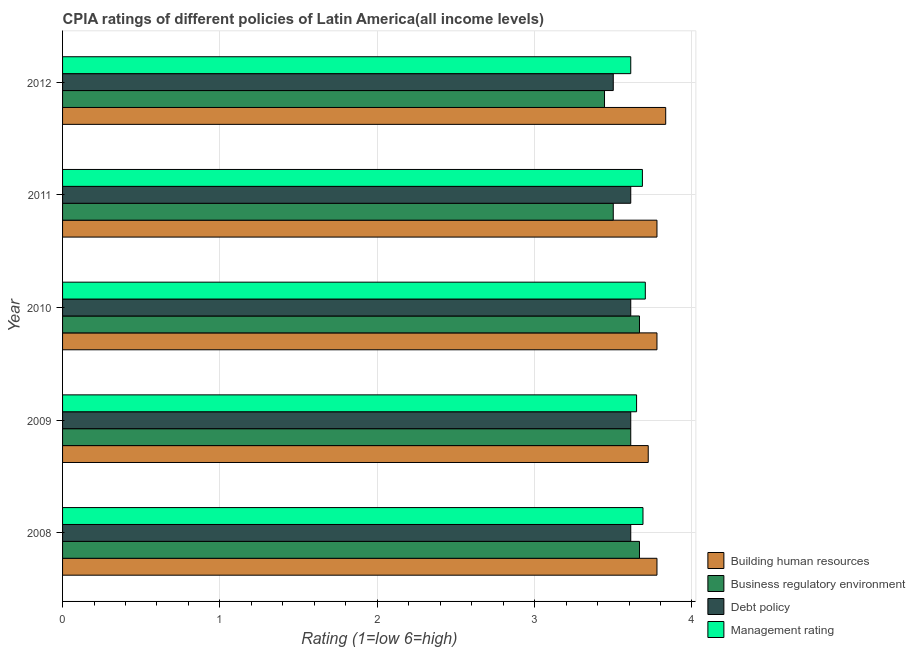Are the number of bars per tick equal to the number of legend labels?
Provide a short and direct response. Yes. What is the label of the 1st group of bars from the top?
Provide a short and direct response. 2012. In how many cases, is the number of bars for a given year not equal to the number of legend labels?
Your answer should be very brief. 0. What is the cpia rating of management in 2012?
Provide a succinct answer. 3.61. Across all years, what is the maximum cpia rating of business regulatory environment?
Keep it short and to the point. 3.67. Across all years, what is the minimum cpia rating of management?
Keep it short and to the point. 3.61. In which year was the cpia rating of debt policy maximum?
Your answer should be very brief. 2008. What is the total cpia rating of business regulatory environment in the graph?
Ensure brevity in your answer.  17.89. What is the difference between the cpia rating of business regulatory environment in 2009 and the cpia rating of building human resources in 2010?
Make the answer very short. -0.17. What is the average cpia rating of debt policy per year?
Make the answer very short. 3.59. In the year 2012, what is the difference between the cpia rating of management and cpia rating of business regulatory environment?
Your answer should be very brief. 0.17. In how many years, is the cpia rating of management greater than 2.6 ?
Keep it short and to the point. 5. What is the ratio of the cpia rating of debt policy in 2009 to that in 2011?
Give a very brief answer. 1. Is the difference between the cpia rating of business regulatory environment in 2011 and 2012 greater than the difference between the cpia rating of debt policy in 2011 and 2012?
Provide a succinct answer. No. What is the difference between the highest and the second highest cpia rating of building human resources?
Provide a succinct answer. 0.06. What is the difference between the highest and the lowest cpia rating of debt policy?
Ensure brevity in your answer.  0.11. Is it the case that in every year, the sum of the cpia rating of business regulatory environment and cpia rating of management is greater than the sum of cpia rating of building human resources and cpia rating of debt policy?
Give a very brief answer. No. What does the 3rd bar from the top in 2009 represents?
Offer a very short reply. Business regulatory environment. What does the 3rd bar from the bottom in 2008 represents?
Provide a short and direct response. Debt policy. Are all the bars in the graph horizontal?
Ensure brevity in your answer.  Yes. How many years are there in the graph?
Keep it short and to the point. 5. Are the values on the major ticks of X-axis written in scientific E-notation?
Provide a succinct answer. No. Does the graph contain any zero values?
Your answer should be compact. No. How are the legend labels stacked?
Offer a terse response. Vertical. What is the title of the graph?
Your answer should be compact. CPIA ratings of different policies of Latin America(all income levels). Does "Luxembourg" appear as one of the legend labels in the graph?
Provide a short and direct response. No. What is the label or title of the Y-axis?
Ensure brevity in your answer.  Year. What is the Rating (1=low 6=high) in Building human resources in 2008?
Make the answer very short. 3.78. What is the Rating (1=low 6=high) in Business regulatory environment in 2008?
Make the answer very short. 3.67. What is the Rating (1=low 6=high) of Debt policy in 2008?
Your answer should be very brief. 3.61. What is the Rating (1=low 6=high) in Management rating in 2008?
Keep it short and to the point. 3.69. What is the Rating (1=low 6=high) of Building human resources in 2009?
Offer a very short reply. 3.72. What is the Rating (1=low 6=high) in Business regulatory environment in 2009?
Your response must be concise. 3.61. What is the Rating (1=low 6=high) of Debt policy in 2009?
Your answer should be compact. 3.61. What is the Rating (1=low 6=high) in Management rating in 2009?
Offer a terse response. 3.65. What is the Rating (1=low 6=high) of Building human resources in 2010?
Your answer should be very brief. 3.78. What is the Rating (1=low 6=high) in Business regulatory environment in 2010?
Make the answer very short. 3.67. What is the Rating (1=low 6=high) of Debt policy in 2010?
Provide a succinct answer. 3.61. What is the Rating (1=low 6=high) in Management rating in 2010?
Ensure brevity in your answer.  3.7. What is the Rating (1=low 6=high) in Building human resources in 2011?
Provide a succinct answer. 3.78. What is the Rating (1=low 6=high) of Debt policy in 2011?
Make the answer very short. 3.61. What is the Rating (1=low 6=high) in Management rating in 2011?
Your response must be concise. 3.69. What is the Rating (1=low 6=high) of Building human resources in 2012?
Provide a succinct answer. 3.83. What is the Rating (1=low 6=high) in Business regulatory environment in 2012?
Make the answer very short. 3.44. What is the Rating (1=low 6=high) of Management rating in 2012?
Provide a succinct answer. 3.61. Across all years, what is the maximum Rating (1=low 6=high) in Building human resources?
Your answer should be very brief. 3.83. Across all years, what is the maximum Rating (1=low 6=high) of Business regulatory environment?
Make the answer very short. 3.67. Across all years, what is the maximum Rating (1=low 6=high) of Debt policy?
Offer a very short reply. 3.61. Across all years, what is the maximum Rating (1=low 6=high) in Management rating?
Offer a very short reply. 3.7. Across all years, what is the minimum Rating (1=low 6=high) of Building human resources?
Keep it short and to the point. 3.72. Across all years, what is the minimum Rating (1=low 6=high) in Business regulatory environment?
Give a very brief answer. 3.44. Across all years, what is the minimum Rating (1=low 6=high) of Debt policy?
Provide a short and direct response. 3.5. Across all years, what is the minimum Rating (1=low 6=high) in Management rating?
Your answer should be very brief. 3.61. What is the total Rating (1=low 6=high) of Building human resources in the graph?
Ensure brevity in your answer.  18.89. What is the total Rating (1=low 6=high) in Business regulatory environment in the graph?
Offer a terse response. 17.89. What is the total Rating (1=low 6=high) of Debt policy in the graph?
Your answer should be compact. 17.94. What is the total Rating (1=low 6=high) in Management rating in the graph?
Keep it short and to the point. 18.34. What is the difference between the Rating (1=low 6=high) of Building human resources in 2008 and that in 2009?
Your answer should be very brief. 0.06. What is the difference between the Rating (1=low 6=high) of Business regulatory environment in 2008 and that in 2009?
Your response must be concise. 0.06. What is the difference between the Rating (1=low 6=high) in Management rating in 2008 and that in 2009?
Ensure brevity in your answer.  0.04. What is the difference between the Rating (1=low 6=high) of Building human resources in 2008 and that in 2010?
Offer a very short reply. 0. What is the difference between the Rating (1=low 6=high) in Business regulatory environment in 2008 and that in 2010?
Your response must be concise. 0. What is the difference between the Rating (1=low 6=high) of Debt policy in 2008 and that in 2010?
Your answer should be very brief. 0. What is the difference between the Rating (1=low 6=high) of Management rating in 2008 and that in 2010?
Keep it short and to the point. -0.01. What is the difference between the Rating (1=low 6=high) of Management rating in 2008 and that in 2011?
Offer a very short reply. 0. What is the difference between the Rating (1=low 6=high) of Building human resources in 2008 and that in 2012?
Make the answer very short. -0.06. What is the difference between the Rating (1=low 6=high) of Business regulatory environment in 2008 and that in 2012?
Your answer should be compact. 0.22. What is the difference between the Rating (1=low 6=high) in Debt policy in 2008 and that in 2012?
Keep it short and to the point. 0.11. What is the difference between the Rating (1=low 6=high) of Management rating in 2008 and that in 2012?
Offer a terse response. 0.08. What is the difference between the Rating (1=low 6=high) in Building human resources in 2009 and that in 2010?
Offer a terse response. -0.06. What is the difference between the Rating (1=low 6=high) in Business regulatory environment in 2009 and that in 2010?
Your answer should be compact. -0.06. What is the difference between the Rating (1=low 6=high) of Debt policy in 2009 and that in 2010?
Give a very brief answer. 0. What is the difference between the Rating (1=low 6=high) of Management rating in 2009 and that in 2010?
Ensure brevity in your answer.  -0.06. What is the difference between the Rating (1=low 6=high) in Building human resources in 2009 and that in 2011?
Give a very brief answer. -0.06. What is the difference between the Rating (1=low 6=high) of Business regulatory environment in 2009 and that in 2011?
Your answer should be very brief. 0.11. What is the difference between the Rating (1=low 6=high) in Debt policy in 2009 and that in 2011?
Make the answer very short. 0. What is the difference between the Rating (1=low 6=high) of Management rating in 2009 and that in 2011?
Give a very brief answer. -0.04. What is the difference between the Rating (1=low 6=high) in Building human resources in 2009 and that in 2012?
Your response must be concise. -0.11. What is the difference between the Rating (1=low 6=high) of Management rating in 2009 and that in 2012?
Ensure brevity in your answer.  0.04. What is the difference between the Rating (1=low 6=high) in Building human resources in 2010 and that in 2011?
Ensure brevity in your answer.  0. What is the difference between the Rating (1=low 6=high) in Business regulatory environment in 2010 and that in 2011?
Provide a short and direct response. 0.17. What is the difference between the Rating (1=low 6=high) in Management rating in 2010 and that in 2011?
Provide a succinct answer. 0.02. What is the difference between the Rating (1=low 6=high) in Building human resources in 2010 and that in 2012?
Offer a very short reply. -0.06. What is the difference between the Rating (1=low 6=high) in Business regulatory environment in 2010 and that in 2012?
Offer a very short reply. 0.22. What is the difference between the Rating (1=low 6=high) in Debt policy in 2010 and that in 2012?
Offer a very short reply. 0.11. What is the difference between the Rating (1=low 6=high) of Management rating in 2010 and that in 2012?
Offer a very short reply. 0.09. What is the difference between the Rating (1=low 6=high) of Building human resources in 2011 and that in 2012?
Give a very brief answer. -0.06. What is the difference between the Rating (1=low 6=high) of Business regulatory environment in 2011 and that in 2012?
Make the answer very short. 0.06. What is the difference between the Rating (1=low 6=high) in Management rating in 2011 and that in 2012?
Ensure brevity in your answer.  0.07. What is the difference between the Rating (1=low 6=high) of Building human resources in 2008 and the Rating (1=low 6=high) of Debt policy in 2009?
Make the answer very short. 0.17. What is the difference between the Rating (1=low 6=high) of Building human resources in 2008 and the Rating (1=low 6=high) of Management rating in 2009?
Your answer should be very brief. 0.13. What is the difference between the Rating (1=low 6=high) of Business regulatory environment in 2008 and the Rating (1=low 6=high) of Debt policy in 2009?
Keep it short and to the point. 0.06. What is the difference between the Rating (1=low 6=high) of Business regulatory environment in 2008 and the Rating (1=low 6=high) of Management rating in 2009?
Keep it short and to the point. 0.02. What is the difference between the Rating (1=low 6=high) of Debt policy in 2008 and the Rating (1=low 6=high) of Management rating in 2009?
Offer a very short reply. -0.04. What is the difference between the Rating (1=low 6=high) in Building human resources in 2008 and the Rating (1=low 6=high) in Business regulatory environment in 2010?
Provide a succinct answer. 0.11. What is the difference between the Rating (1=low 6=high) of Building human resources in 2008 and the Rating (1=low 6=high) of Debt policy in 2010?
Offer a very short reply. 0.17. What is the difference between the Rating (1=low 6=high) in Building human resources in 2008 and the Rating (1=low 6=high) in Management rating in 2010?
Ensure brevity in your answer.  0.07. What is the difference between the Rating (1=low 6=high) in Business regulatory environment in 2008 and the Rating (1=low 6=high) in Debt policy in 2010?
Give a very brief answer. 0.06. What is the difference between the Rating (1=low 6=high) in Business regulatory environment in 2008 and the Rating (1=low 6=high) in Management rating in 2010?
Your answer should be compact. -0.04. What is the difference between the Rating (1=low 6=high) in Debt policy in 2008 and the Rating (1=low 6=high) in Management rating in 2010?
Give a very brief answer. -0.09. What is the difference between the Rating (1=low 6=high) of Building human resources in 2008 and the Rating (1=low 6=high) of Business regulatory environment in 2011?
Ensure brevity in your answer.  0.28. What is the difference between the Rating (1=low 6=high) of Building human resources in 2008 and the Rating (1=low 6=high) of Management rating in 2011?
Provide a short and direct response. 0.09. What is the difference between the Rating (1=low 6=high) of Business regulatory environment in 2008 and the Rating (1=low 6=high) of Debt policy in 2011?
Your response must be concise. 0.06. What is the difference between the Rating (1=low 6=high) of Business regulatory environment in 2008 and the Rating (1=low 6=high) of Management rating in 2011?
Your response must be concise. -0.02. What is the difference between the Rating (1=low 6=high) in Debt policy in 2008 and the Rating (1=low 6=high) in Management rating in 2011?
Keep it short and to the point. -0.07. What is the difference between the Rating (1=low 6=high) of Building human resources in 2008 and the Rating (1=low 6=high) of Business regulatory environment in 2012?
Provide a short and direct response. 0.33. What is the difference between the Rating (1=low 6=high) in Building human resources in 2008 and the Rating (1=low 6=high) in Debt policy in 2012?
Give a very brief answer. 0.28. What is the difference between the Rating (1=low 6=high) of Business regulatory environment in 2008 and the Rating (1=low 6=high) of Management rating in 2012?
Offer a terse response. 0.06. What is the difference between the Rating (1=low 6=high) in Debt policy in 2008 and the Rating (1=low 6=high) in Management rating in 2012?
Offer a very short reply. 0. What is the difference between the Rating (1=low 6=high) of Building human resources in 2009 and the Rating (1=low 6=high) of Business regulatory environment in 2010?
Offer a terse response. 0.06. What is the difference between the Rating (1=low 6=high) in Building human resources in 2009 and the Rating (1=low 6=high) in Debt policy in 2010?
Provide a short and direct response. 0.11. What is the difference between the Rating (1=low 6=high) of Building human resources in 2009 and the Rating (1=low 6=high) of Management rating in 2010?
Ensure brevity in your answer.  0.02. What is the difference between the Rating (1=low 6=high) of Business regulatory environment in 2009 and the Rating (1=low 6=high) of Management rating in 2010?
Make the answer very short. -0.09. What is the difference between the Rating (1=low 6=high) in Debt policy in 2009 and the Rating (1=low 6=high) in Management rating in 2010?
Provide a short and direct response. -0.09. What is the difference between the Rating (1=low 6=high) of Building human resources in 2009 and the Rating (1=low 6=high) of Business regulatory environment in 2011?
Offer a terse response. 0.22. What is the difference between the Rating (1=low 6=high) in Building human resources in 2009 and the Rating (1=low 6=high) in Debt policy in 2011?
Keep it short and to the point. 0.11. What is the difference between the Rating (1=low 6=high) in Building human resources in 2009 and the Rating (1=low 6=high) in Management rating in 2011?
Give a very brief answer. 0.04. What is the difference between the Rating (1=low 6=high) of Business regulatory environment in 2009 and the Rating (1=low 6=high) of Management rating in 2011?
Your response must be concise. -0.07. What is the difference between the Rating (1=low 6=high) in Debt policy in 2009 and the Rating (1=low 6=high) in Management rating in 2011?
Give a very brief answer. -0.07. What is the difference between the Rating (1=low 6=high) in Building human resources in 2009 and the Rating (1=low 6=high) in Business regulatory environment in 2012?
Make the answer very short. 0.28. What is the difference between the Rating (1=low 6=high) in Building human resources in 2009 and the Rating (1=low 6=high) in Debt policy in 2012?
Your answer should be very brief. 0.22. What is the difference between the Rating (1=low 6=high) in Building human resources in 2009 and the Rating (1=low 6=high) in Management rating in 2012?
Give a very brief answer. 0.11. What is the difference between the Rating (1=low 6=high) of Business regulatory environment in 2009 and the Rating (1=low 6=high) of Debt policy in 2012?
Your answer should be very brief. 0.11. What is the difference between the Rating (1=low 6=high) of Debt policy in 2009 and the Rating (1=low 6=high) of Management rating in 2012?
Make the answer very short. 0. What is the difference between the Rating (1=low 6=high) of Building human resources in 2010 and the Rating (1=low 6=high) of Business regulatory environment in 2011?
Your answer should be compact. 0.28. What is the difference between the Rating (1=low 6=high) in Building human resources in 2010 and the Rating (1=low 6=high) in Debt policy in 2011?
Your answer should be compact. 0.17. What is the difference between the Rating (1=low 6=high) in Building human resources in 2010 and the Rating (1=low 6=high) in Management rating in 2011?
Your answer should be compact. 0.09. What is the difference between the Rating (1=low 6=high) in Business regulatory environment in 2010 and the Rating (1=low 6=high) in Debt policy in 2011?
Give a very brief answer. 0.06. What is the difference between the Rating (1=low 6=high) in Business regulatory environment in 2010 and the Rating (1=low 6=high) in Management rating in 2011?
Ensure brevity in your answer.  -0.02. What is the difference between the Rating (1=low 6=high) in Debt policy in 2010 and the Rating (1=low 6=high) in Management rating in 2011?
Offer a terse response. -0.07. What is the difference between the Rating (1=low 6=high) in Building human resources in 2010 and the Rating (1=low 6=high) in Debt policy in 2012?
Offer a terse response. 0.28. What is the difference between the Rating (1=low 6=high) of Building human resources in 2010 and the Rating (1=low 6=high) of Management rating in 2012?
Give a very brief answer. 0.17. What is the difference between the Rating (1=low 6=high) of Business regulatory environment in 2010 and the Rating (1=low 6=high) of Management rating in 2012?
Make the answer very short. 0.06. What is the difference between the Rating (1=low 6=high) in Building human resources in 2011 and the Rating (1=low 6=high) in Business regulatory environment in 2012?
Ensure brevity in your answer.  0.33. What is the difference between the Rating (1=low 6=high) in Building human resources in 2011 and the Rating (1=low 6=high) in Debt policy in 2012?
Provide a short and direct response. 0.28. What is the difference between the Rating (1=low 6=high) of Building human resources in 2011 and the Rating (1=low 6=high) of Management rating in 2012?
Offer a very short reply. 0.17. What is the difference between the Rating (1=low 6=high) of Business regulatory environment in 2011 and the Rating (1=low 6=high) of Debt policy in 2012?
Provide a short and direct response. 0. What is the difference between the Rating (1=low 6=high) in Business regulatory environment in 2011 and the Rating (1=low 6=high) in Management rating in 2012?
Ensure brevity in your answer.  -0.11. What is the difference between the Rating (1=low 6=high) of Debt policy in 2011 and the Rating (1=low 6=high) of Management rating in 2012?
Make the answer very short. 0. What is the average Rating (1=low 6=high) of Building human resources per year?
Your answer should be compact. 3.78. What is the average Rating (1=low 6=high) in Business regulatory environment per year?
Keep it short and to the point. 3.58. What is the average Rating (1=low 6=high) in Debt policy per year?
Give a very brief answer. 3.59. What is the average Rating (1=low 6=high) in Management rating per year?
Your answer should be very brief. 3.67. In the year 2008, what is the difference between the Rating (1=low 6=high) of Building human resources and Rating (1=low 6=high) of Management rating?
Provide a short and direct response. 0.09. In the year 2008, what is the difference between the Rating (1=low 6=high) in Business regulatory environment and Rating (1=low 6=high) in Debt policy?
Ensure brevity in your answer.  0.06. In the year 2008, what is the difference between the Rating (1=low 6=high) of Business regulatory environment and Rating (1=low 6=high) of Management rating?
Provide a short and direct response. -0.02. In the year 2008, what is the difference between the Rating (1=low 6=high) of Debt policy and Rating (1=low 6=high) of Management rating?
Offer a very short reply. -0.08. In the year 2009, what is the difference between the Rating (1=low 6=high) of Building human resources and Rating (1=low 6=high) of Management rating?
Your response must be concise. 0.07. In the year 2009, what is the difference between the Rating (1=low 6=high) in Business regulatory environment and Rating (1=low 6=high) in Debt policy?
Give a very brief answer. 0. In the year 2009, what is the difference between the Rating (1=low 6=high) in Business regulatory environment and Rating (1=low 6=high) in Management rating?
Keep it short and to the point. -0.04. In the year 2009, what is the difference between the Rating (1=low 6=high) of Debt policy and Rating (1=low 6=high) of Management rating?
Your answer should be very brief. -0.04. In the year 2010, what is the difference between the Rating (1=low 6=high) of Building human resources and Rating (1=low 6=high) of Management rating?
Your answer should be compact. 0.07. In the year 2010, what is the difference between the Rating (1=low 6=high) of Business regulatory environment and Rating (1=low 6=high) of Debt policy?
Provide a succinct answer. 0.06. In the year 2010, what is the difference between the Rating (1=low 6=high) of Business regulatory environment and Rating (1=low 6=high) of Management rating?
Your response must be concise. -0.04. In the year 2010, what is the difference between the Rating (1=low 6=high) in Debt policy and Rating (1=low 6=high) in Management rating?
Provide a short and direct response. -0.09. In the year 2011, what is the difference between the Rating (1=low 6=high) in Building human resources and Rating (1=low 6=high) in Business regulatory environment?
Keep it short and to the point. 0.28. In the year 2011, what is the difference between the Rating (1=low 6=high) in Building human resources and Rating (1=low 6=high) in Debt policy?
Make the answer very short. 0.17. In the year 2011, what is the difference between the Rating (1=low 6=high) in Building human resources and Rating (1=low 6=high) in Management rating?
Provide a short and direct response. 0.09. In the year 2011, what is the difference between the Rating (1=low 6=high) of Business regulatory environment and Rating (1=low 6=high) of Debt policy?
Provide a succinct answer. -0.11. In the year 2011, what is the difference between the Rating (1=low 6=high) of Business regulatory environment and Rating (1=low 6=high) of Management rating?
Ensure brevity in your answer.  -0.19. In the year 2011, what is the difference between the Rating (1=low 6=high) of Debt policy and Rating (1=low 6=high) of Management rating?
Your response must be concise. -0.07. In the year 2012, what is the difference between the Rating (1=low 6=high) in Building human resources and Rating (1=low 6=high) in Business regulatory environment?
Offer a very short reply. 0.39. In the year 2012, what is the difference between the Rating (1=low 6=high) in Building human resources and Rating (1=low 6=high) in Management rating?
Ensure brevity in your answer.  0.22. In the year 2012, what is the difference between the Rating (1=low 6=high) of Business regulatory environment and Rating (1=low 6=high) of Debt policy?
Your response must be concise. -0.06. In the year 2012, what is the difference between the Rating (1=low 6=high) of Debt policy and Rating (1=low 6=high) of Management rating?
Make the answer very short. -0.11. What is the ratio of the Rating (1=low 6=high) of Building human resources in 2008 to that in 2009?
Provide a short and direct response. 1.01. What is the ratio of the Rating (1=low 6=high) of Business regulatory environment in 2008 to that in 2009?
Make the answer very short. 1.02. What is the ratio of the Rating (1=low 6=high) of Debt policy in 2008 to that in 2009?
Provide a short and direct response. 1. What is the ratio of the Rating (1=low 6=high) in Management rating in 2008 to that in 2009?
Your answer should be compact. 1.01. What is the ratio of the Rating (1=low 6=high) in Building human resources in 2008 to that in 2010?
Offer a very short reply. 1. What is the ratio of the Rating (1=low 6=high) in Business regulatory environment in 2008 to that in 2010?
Your answer should be compact. 1. What is the ratio of the Rating (1=low 6=high) of Management rating in 2008 to that in 2010?
Your response must be concise. 1. What is the ratio of the Rating (1=low 6=high) in Building human resources in 2008 to that in 2011?
Your response must be concise. 1. What is the ratio of the Rating (1=low 6=high) of Business regulatory environment in 2008 to that in 2011?
Keep it short and to the point. 1.05. What is the ratio of the Rating (1=low 6=high) of Building human resources in 2008 to that in 2012?
Provide a succinct answer. 0.99. What is the ratio of the Rating (1=low 6=high) in Business regulatory environment in 2008 to that in 2012?
Ensure brevity in your answer.  1.06. What is the ratio of the Rating (1=low 6=high) in Debt policy in 2008 to that in 2012?
Your answer should be very brief. 1.03. What is the ratio of the Rating (1=low 6=high) of Management rating in 2008 to that in 2012?
Keep it short and to the point. 1.02. What is the ratio of the Rating (1=low 6=high) in Building human resources in 2009 to that in 2010?
Give a very brief answer. 0.99. What is the ratio of the Rating (1=low 6=high) of Business regulatory environment in 2009 to that in 2010?
Your answer should be compact. 0.98. What is the ratio of the Rating (1=low 6=high) of Debt policy in 2009 to that in 2010?
Offer a terse response. 1. What is the ratio of the Rating (1=low 6=high) in Business regulatory environment in 2009 to that in 2011?
Your answer should be very brief. 1.03. What is the ratio of the Rating (1=low 6=high) of Debt policy in 2009 to that in 2011?
Provide a short and direct response. 1. What is the ratio of the Rating (1=low 6=high) of Management rating in 2009 to that in 2011?
Your response must be concise. 0.99. What is the ratio of the Rating (1=low 6=high) in Business regulatory environment in 2009 to that in 2012?
Your response must be concise. 1.05. What is the ratio of the Rating (1=low 6=high) in Debt policy in 2009 to that in 2012?
Keep it short and to the point. 1.03. What is the ratio of the Rating (1=low 6=high) in Management rating in 2009 to that in 2012?
Ensure brevity in your answer.  1.01. What is the ratio of the Rating (1=low 6=high) in Building human resources in 2010 to that in 2011?
Make the answer very short. 1. What is the ratio of the Rating (1=low 6=high) of Business regulatory environment in 2010 to that in 2011?
Provide a short and direct response. 1.05. What is the ratio of the Rating (1=low 6=high) in Debt policy in 2010 to that in 2011?
Your answer should be very brief. 1. What is the ratio of the Rating (1=low 6=high) in Management rating in 2010 to that in 2011?
Make the answer very short. 1. What is the ratio of the Rating (1=low 6=high) in Building human resources in 2010 to that in 2012?
Offer a terse response. 0.99. What is the ratio of the Rating (1=low 6=high) in Business regulatory environment in 2010 to that in 2012?
Your answer should be very brief. 1.06. What is the ratio of the Rating (1=low 6=high) in Debt policy in 2010 to that in 2012?
Provide a succinct answer. 1.03. What is the ratio of the Rating (1=low 6=high) in Management rating in 2010 to that in 2012?
Provide a short and direct response. 1.03. What is the ratio of the Rating (1=low 6=high) of Building human resources in 2011 to that in 2012?
Keep it short and to the point. 0.99. What is the ratio of the Rating (1=low 6=high) in Business regulatory environment in 2011 to that in 2012?
Give a very brief answer. 1.02. What is the ratio of the Rating (1=low 6=high) of Debt policy in 2011 to that in 2012?
Your response must be concise. 1.03. What is the ratio of the Rating (1=low 6=high) in Management rating in 2011 to that in 2012?
Offer a terse response. 1.02. What is the difference between the highest and the second highest Rating (1=low 6=high) of Building human resources?
Your answer should be compact. 0.06. What is the difference between the highest and the second highest Rating (1=low 6=high) of Debt policy?
Keep it short and to the point. 0. What is the difference between the highest and the second highest Rating (1=low 6=high) in Management rating?
Make the answer very short. 0.01. What is the difference between the highest and the lowest Rating (1=low 6=high) in Building human resources?
Your answer should be compact. 0.11. What is the difference between the highest and the lowest Rating (1=low 6=high) of Business regulatory environment?
Give a very brief answer. 0.22. What is the difference between the highest and the lowest Rating (1=low 6=high) of Debt policy?
Your response must be concise. 0.11. What is the difference between the highest and the lowest Rating (1=low 6=high) of Management rating?
Your answer should be very brief. 0.09. 